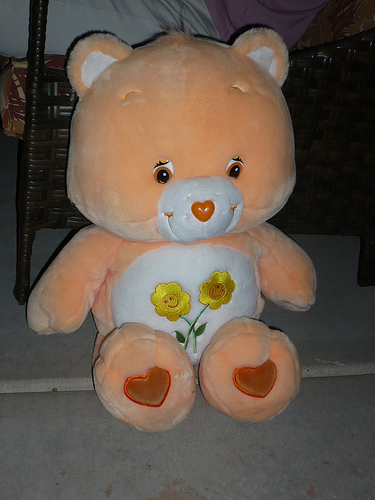<image>
Can you confirm if the line is behind the bed? No. The line is not behind the bed. From this viewpoint, the line appears to be positioned elsewhere in the scene. Is the care bear in front of the brown bed? Yes. The care bear is positioned in front of the brown bed, appearing closer to the camera viewpoint. 